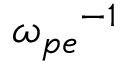<formula> <loc_0><loc_0><loc_500><loc_500>{ \omega _ { p e } } ^ { - 1 }</formula> 